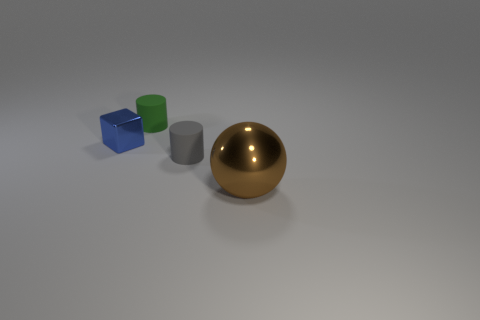Add 3 yellow matte cubes. How many objects exist? 7 Subtract all balls. How many objects are left? 3 Add 4 large cyan spheres. How many large cyan spheres exist? 4 Subtract 0 yellow cubes. How many objects are left? 4 Subtract all small green matte cylinders. Subtract all tiny gray cylinders. How many objects are left? 2 Add 3 large metal balls. How many large metal balls are left? 4 